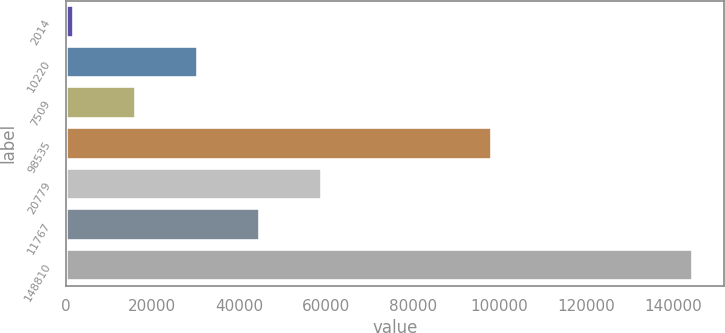Convert chart. <chart><loc_0><loc_0><loc_500><loc_500><bar_chart><fcel>2014<fcel>10220<fcel>7509<fcel>98535<fcel>20779<fcel>11767<fcel>148810<nl><fcel>2013<fcel>30525.6<fcel>16269.3<fcel>98354<fcel>59038.2<fcel>44781.9<fcel>144576<nl></chart> 